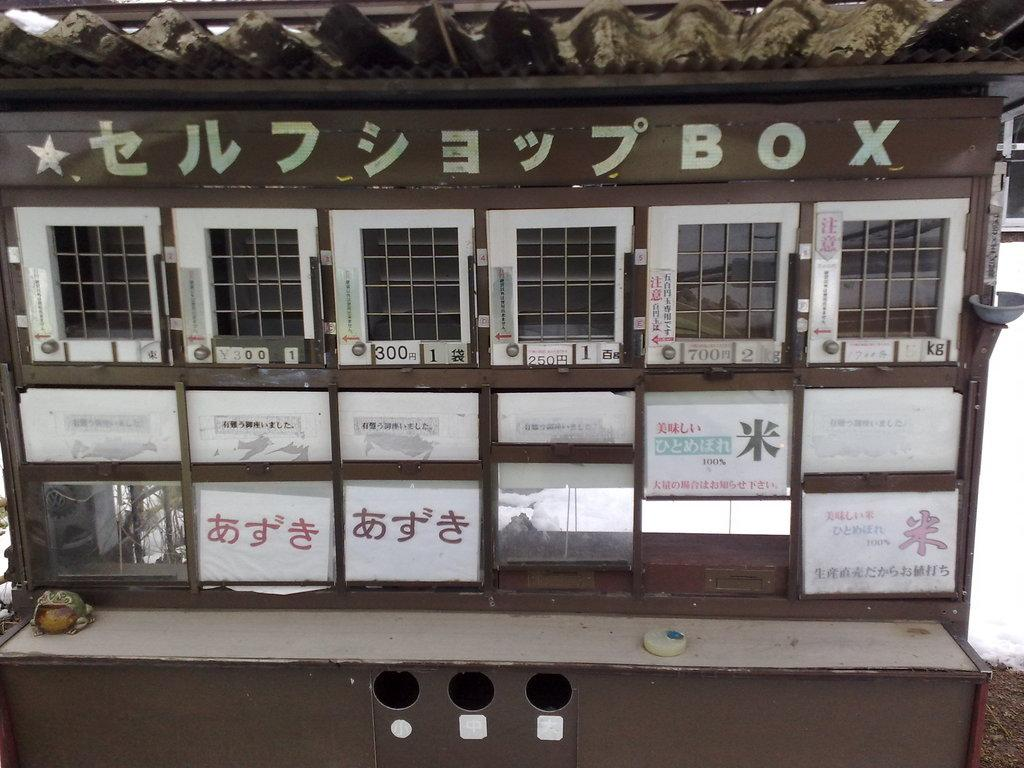Provide a one-sentence caption for the provided image. Several metal boxes on a wooden structure in Japan. 